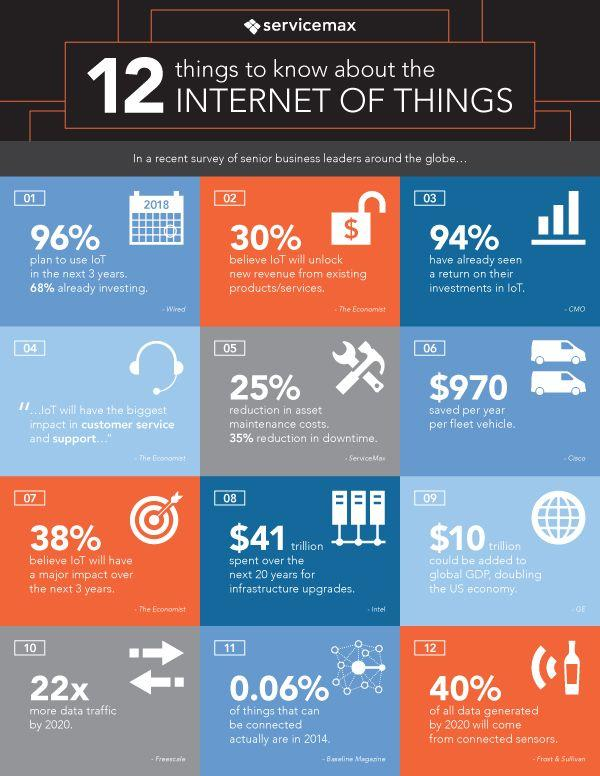Give some essential details in this illustration. Ninety-six percent of respondents plan to incorporate IoT in the next three years. The proposed infrastructure plan would allow for a total of $41 trillion to be spent on infrastructure upgrades over the next 20 years. According to a recent survey, a staggering 94% of senior business leaders have reported a return on their investments in IoT. It is estimated that approximately $10 trillion could be added to double the US economy. 